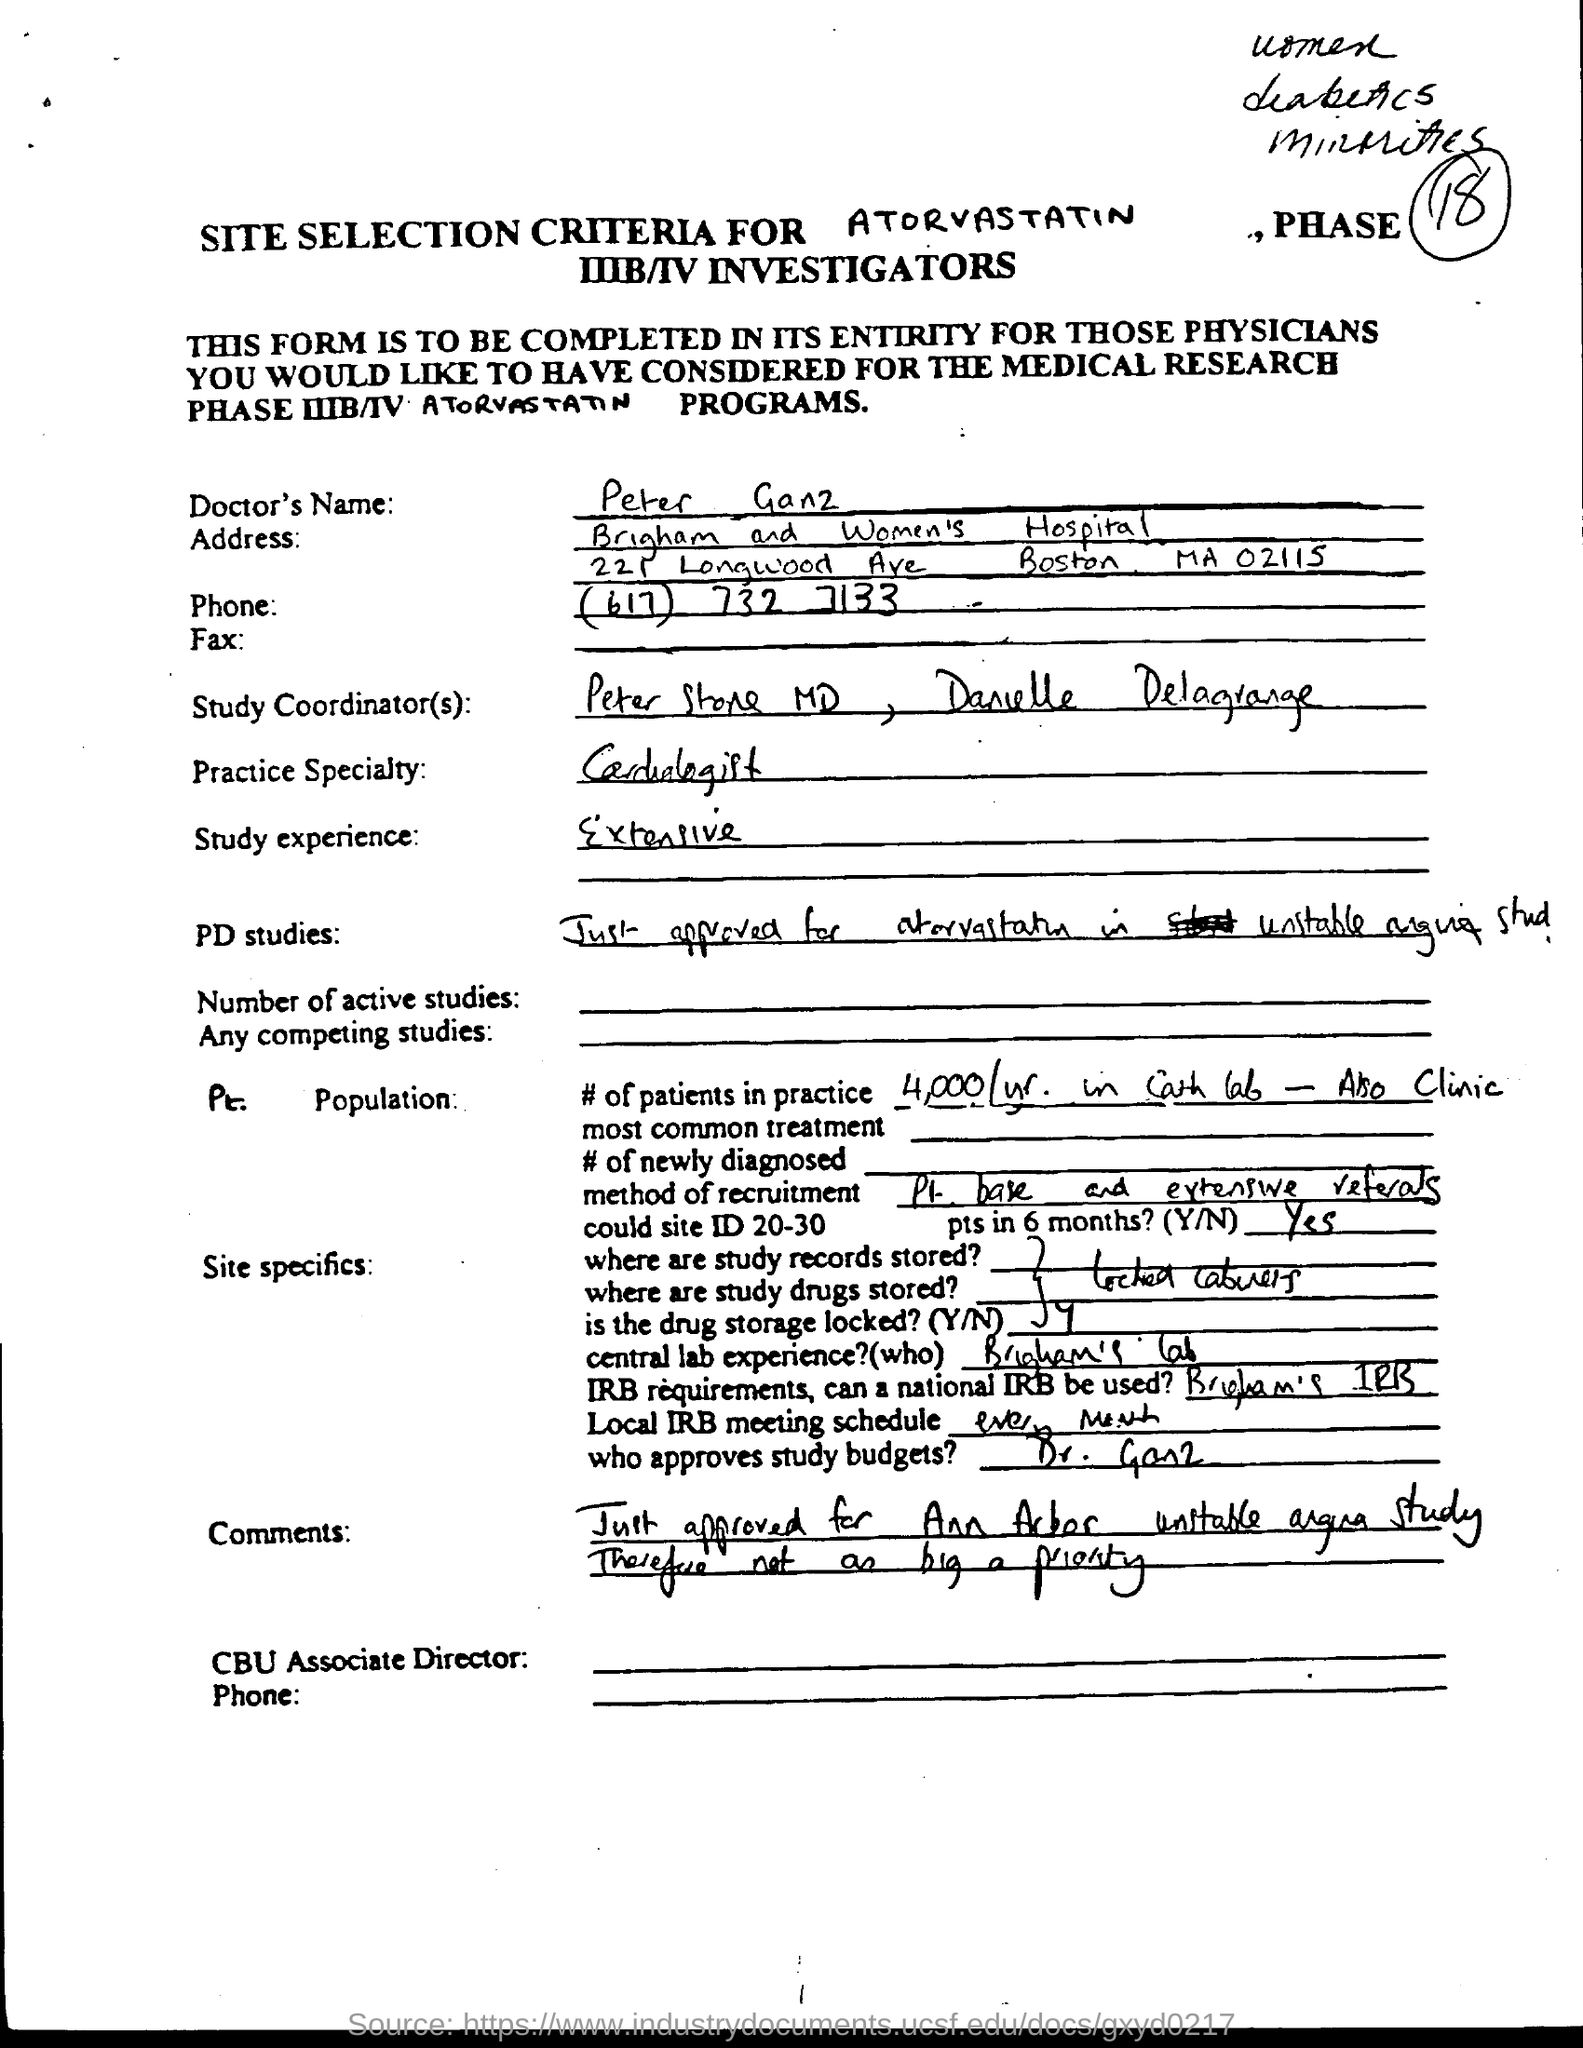What is the Doctor's Name?
Offer a very short reply. Peter Ganz. What is the Doctor's study experience?
Keep it short and to the point. Extensive. What is the Doctor's Practice Specialty?
Offer a very short reply. Cardiologist. 